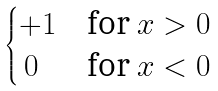Convert formula to latex. <formula><loc_0><loc_0><loc_500><loc_500>\begin{cases} + 1 & \text {for $x > 0$} \\ \, 0 & \text {for $x < 0$} \end{cases}</formula> 